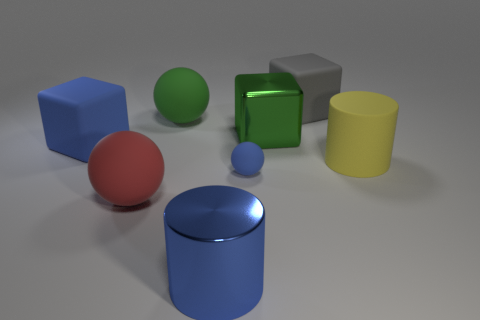What number of metal things are either green objects or small gray objects?
Provide a succinct answer. 1. Are there any red cylinders that have the same size as the green shiny cube?
Ensure brevity in your answer.  No. What is the shape of the large metal object that is the same color as the tiny ball?
Keep it short and to the point. Cylinder. How many metal cubes are the same size as the yellow cylinder?
Your response must be concise. 1. There is a blue object that is left of the red sphere; does it have the same size as the ball right of the metal cylinder?
Your answer should be compact. No. How many things are either small blue matte spheres or objects behind the blue matte block?
Your answer should be compact. 4. The tiny matte ball is what color?
Make the answer very short. Blue. What material is the large blue object that is in front of the big cylinder that is behind the cylinder that is to the left of the small rubber ball?
Give a very brief answer. Metal. What size is the other block that is made of the same material as the blue block?
Provide a short and direct response. Large. Is there a object that has the same color as the large metallic block?
Give a very brief answer. Yes. 